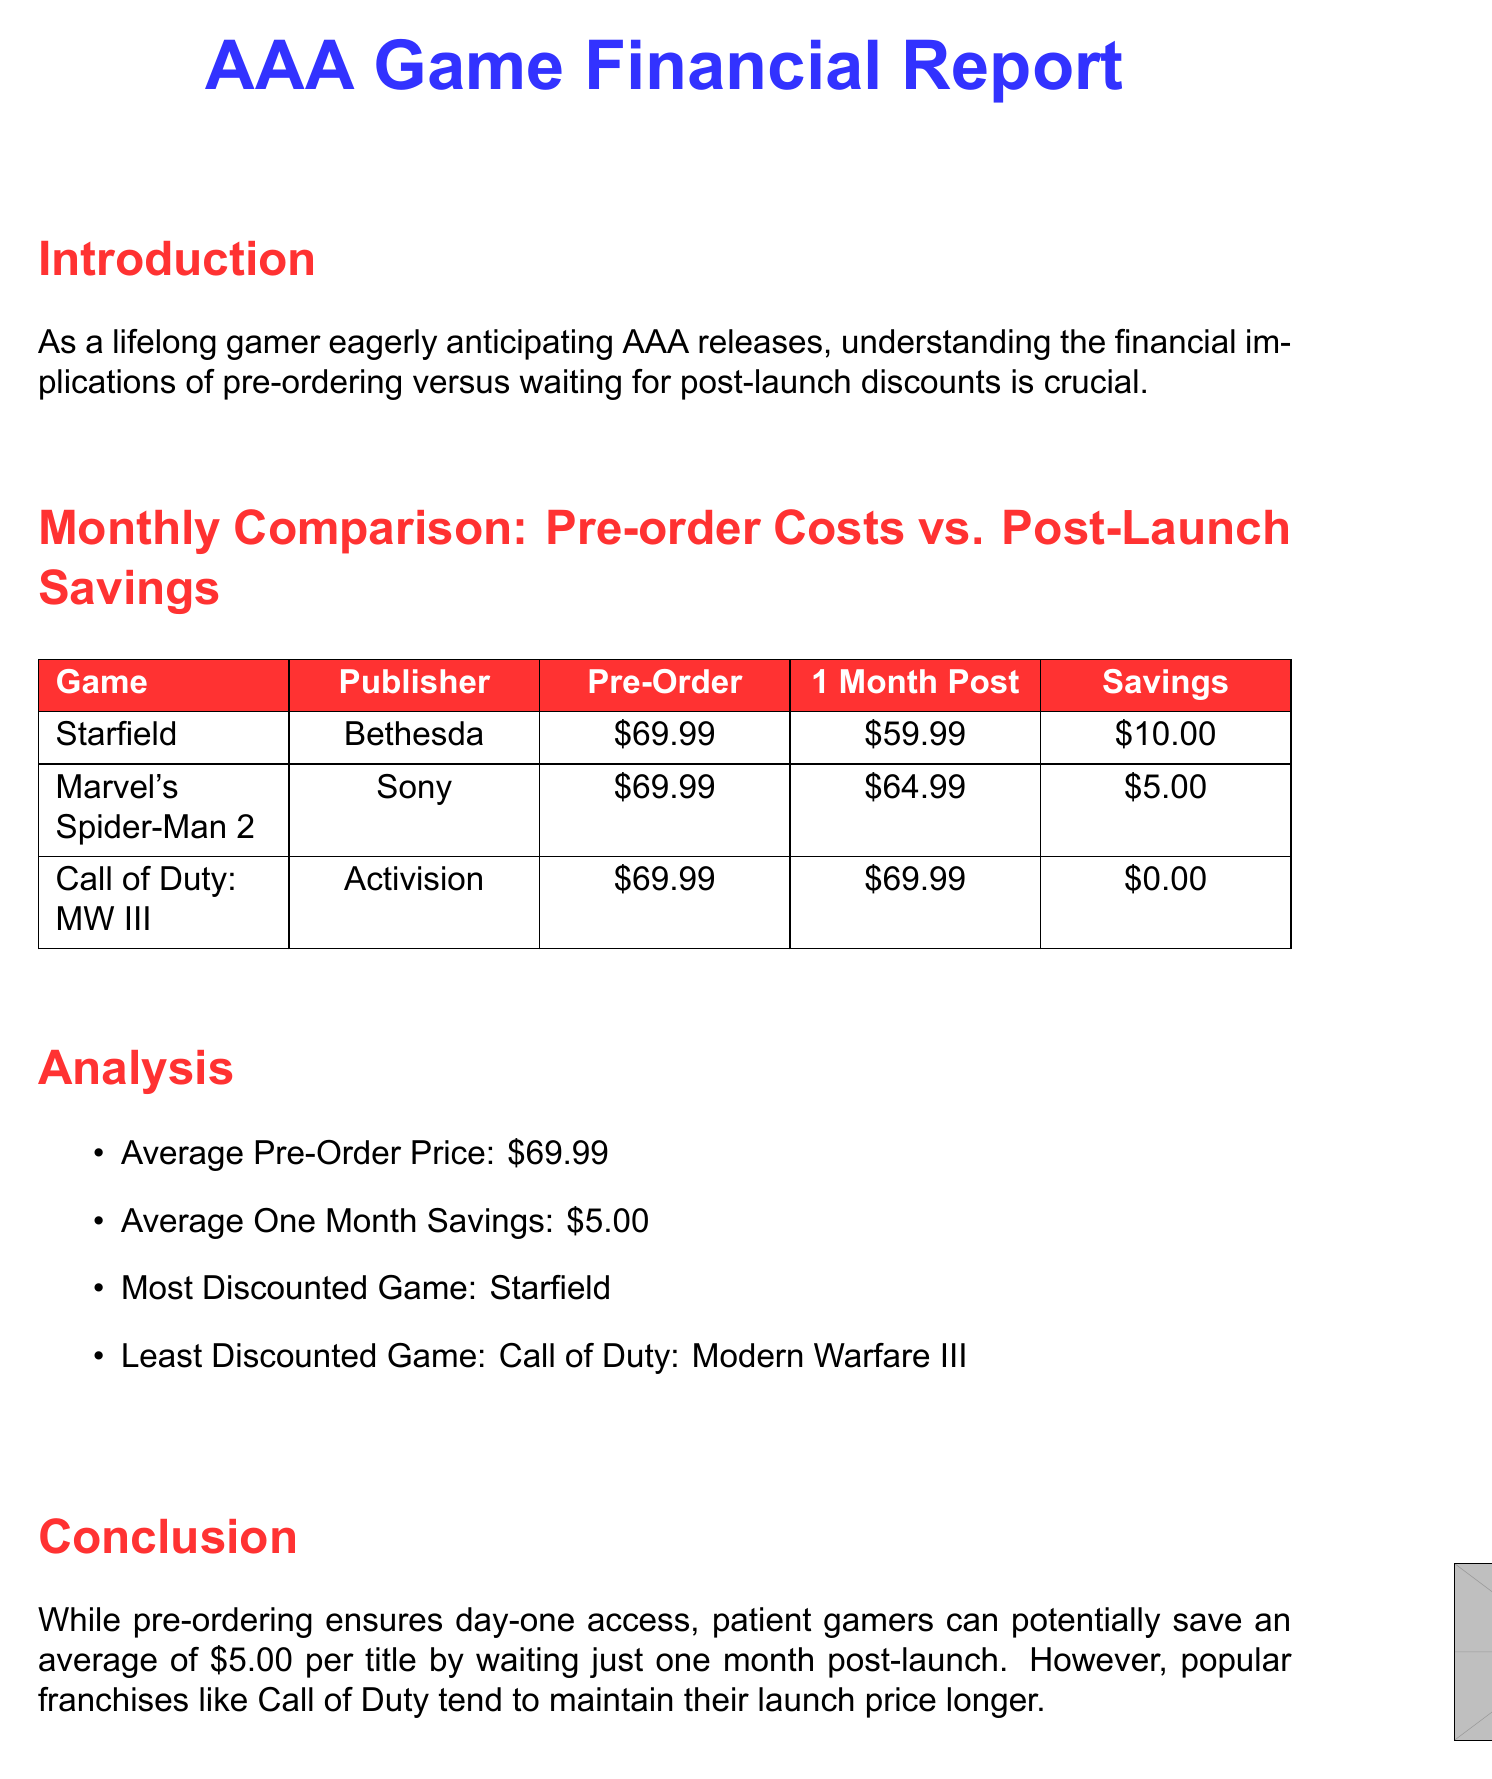What is the pre-order price for Starfield? The pre-order price for Starfield is listed in the document as $69.99.
Answer: $69.99 What is the savings for Marvel's Spider-Man 2? The savings for Marvel's Spider-Man 2 is calculated by subtracting the post-launch price ($64.99) from the pre-order price ($69.99), resulting in $5.00.
Answer: $5.00 Which game has the most discount? The document identifies Starfield as the most discounted game, with a savings of $10.00.
Answer: Starfield What is the average one month savings? The average one month savings is provided in the analysis section as $5.00, which is the average savings across the games listed.
Answer: $5.00 Which game maintained its launch price post-launch? The document states that Call of Duty: Modern Warfare III maintained its price post-launch without any discounts.
Answer: Call of Duty: Modern Warfare III What month is Starfield mentioned in? Starfield is mentioned in September 2023 in the data points section of the document.
Answer: September 2023 What is the total number of games analyzed in this report? The document includes three games in the monthly comparison data, as shown in the table.
Answer: Three What is the conclusion regarding pre-ordering versus waiting? The conclusion states that waiting potentially saves players an average of $5.00 per title compared to pre-ordering.
Answer: $5.00 What publisher released Marvel's Spider-Man 2? The document identifies Sony Interactive Entertainment as the publisher for Marvel's Spider-Man 2.
Answer: Sony Interactive Entertainment 